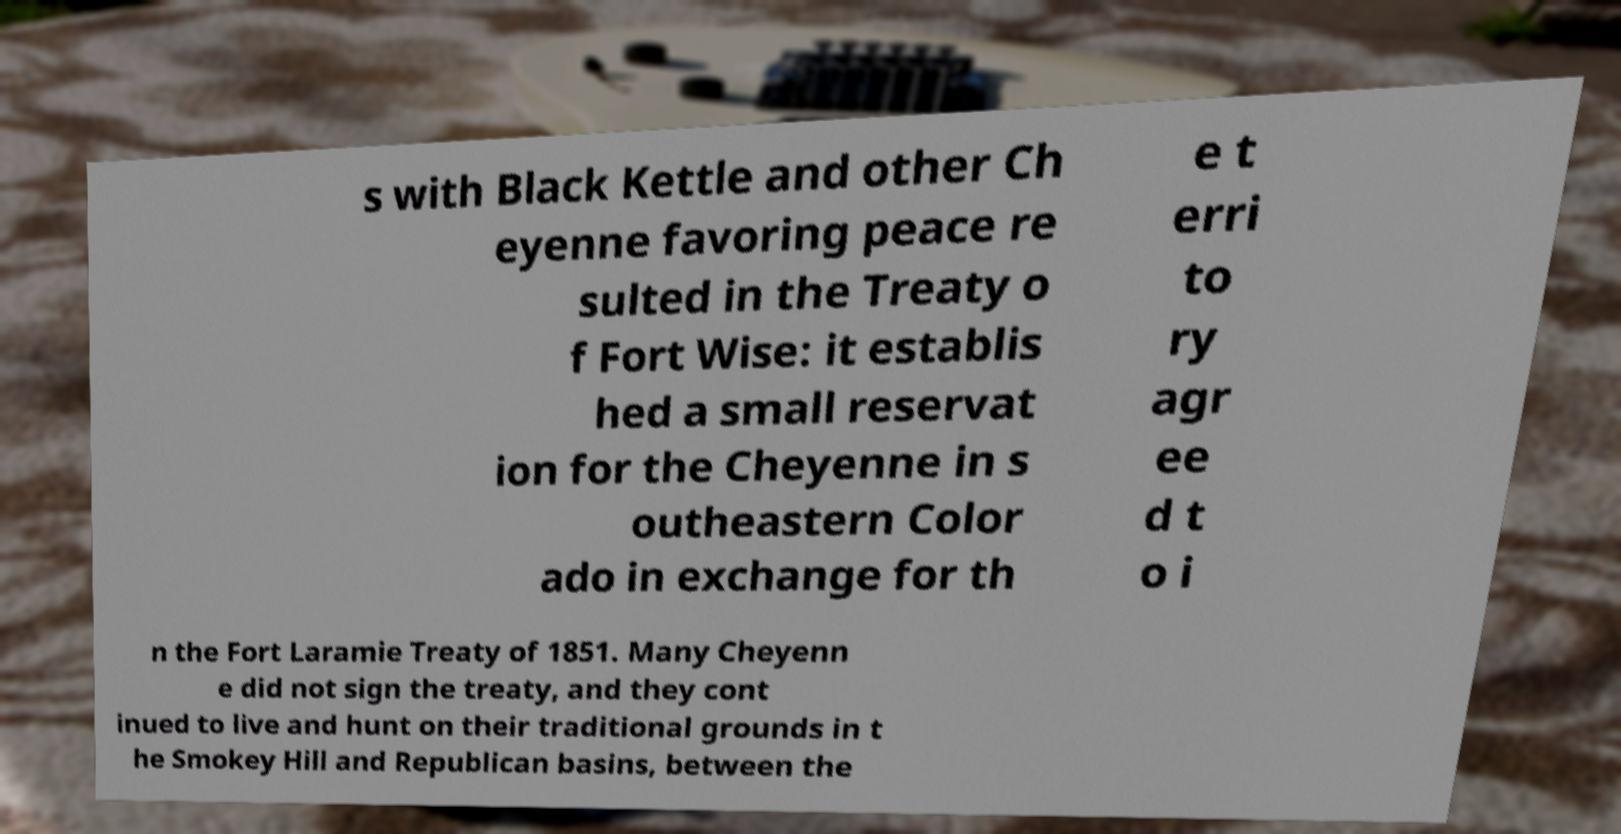Can you read and provide the text displayed in the image?This photo seems to have some interesting text. Can you extract and type it out for me? s with Black Kettle and other Ch eyenne favoring peace re sulted in the Treaty o f Fort Wise: it establis hed a small reservat ion for the Cheyenne in s outheastern Color ado in exchange for th e t erri to ry agr ee d t o i n the Fort Laramie Treaty of 1851. Many Cheyenn e did not sign the treaty, and they cont inued to live and hunt on their traditional grounds in t he Smokey Hill and Republican basins, between the 